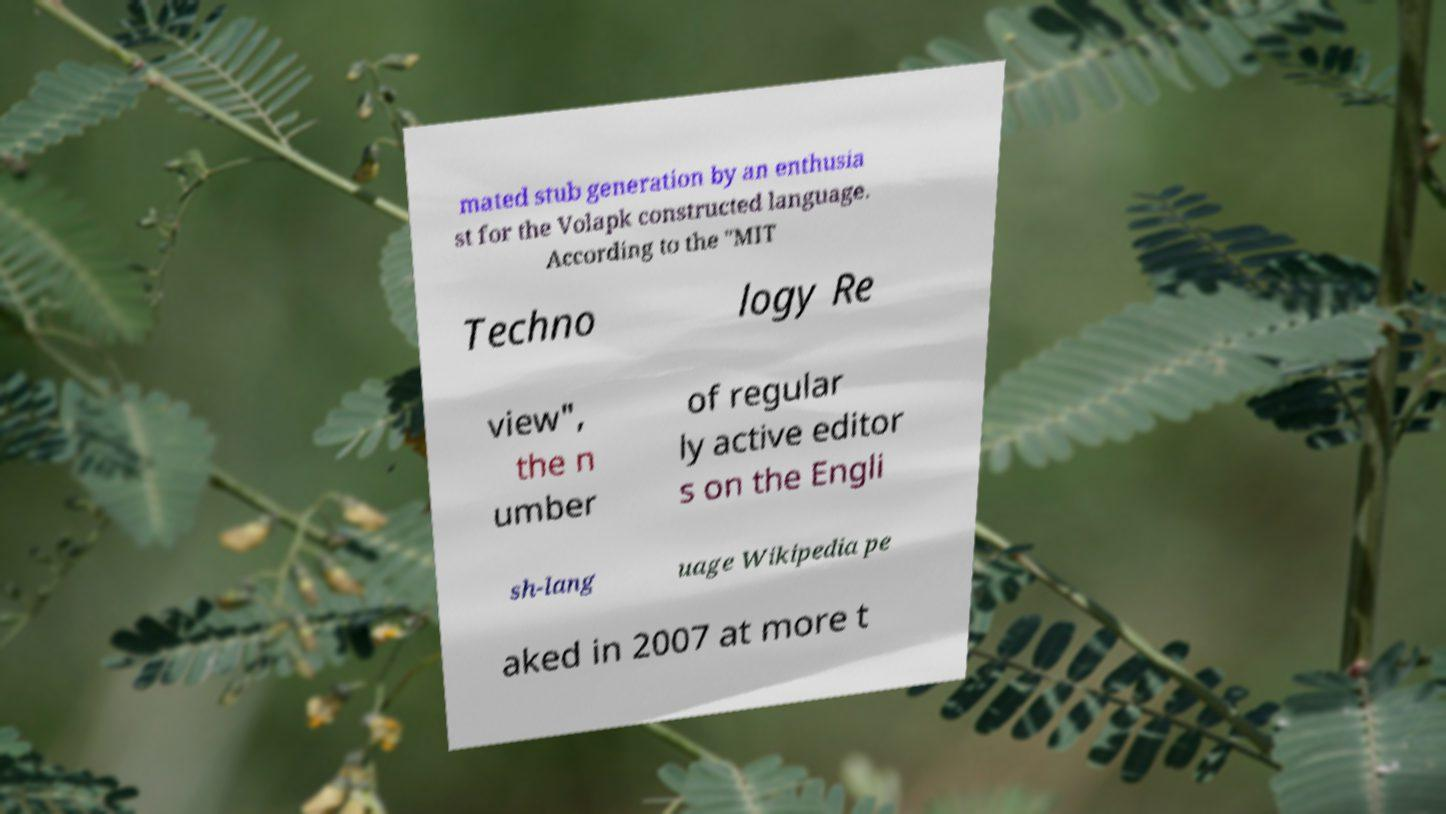What messages or text are displayed in this image? I need them in a readable, typed format. mated stub generation by an enthusia st for the Volapk constructed language. According to the "MIT Techno logy Re view", the n umber of regular ly active editor s on the Engli sh-lang uage Wikipedia pe aked in 2007 at more t 